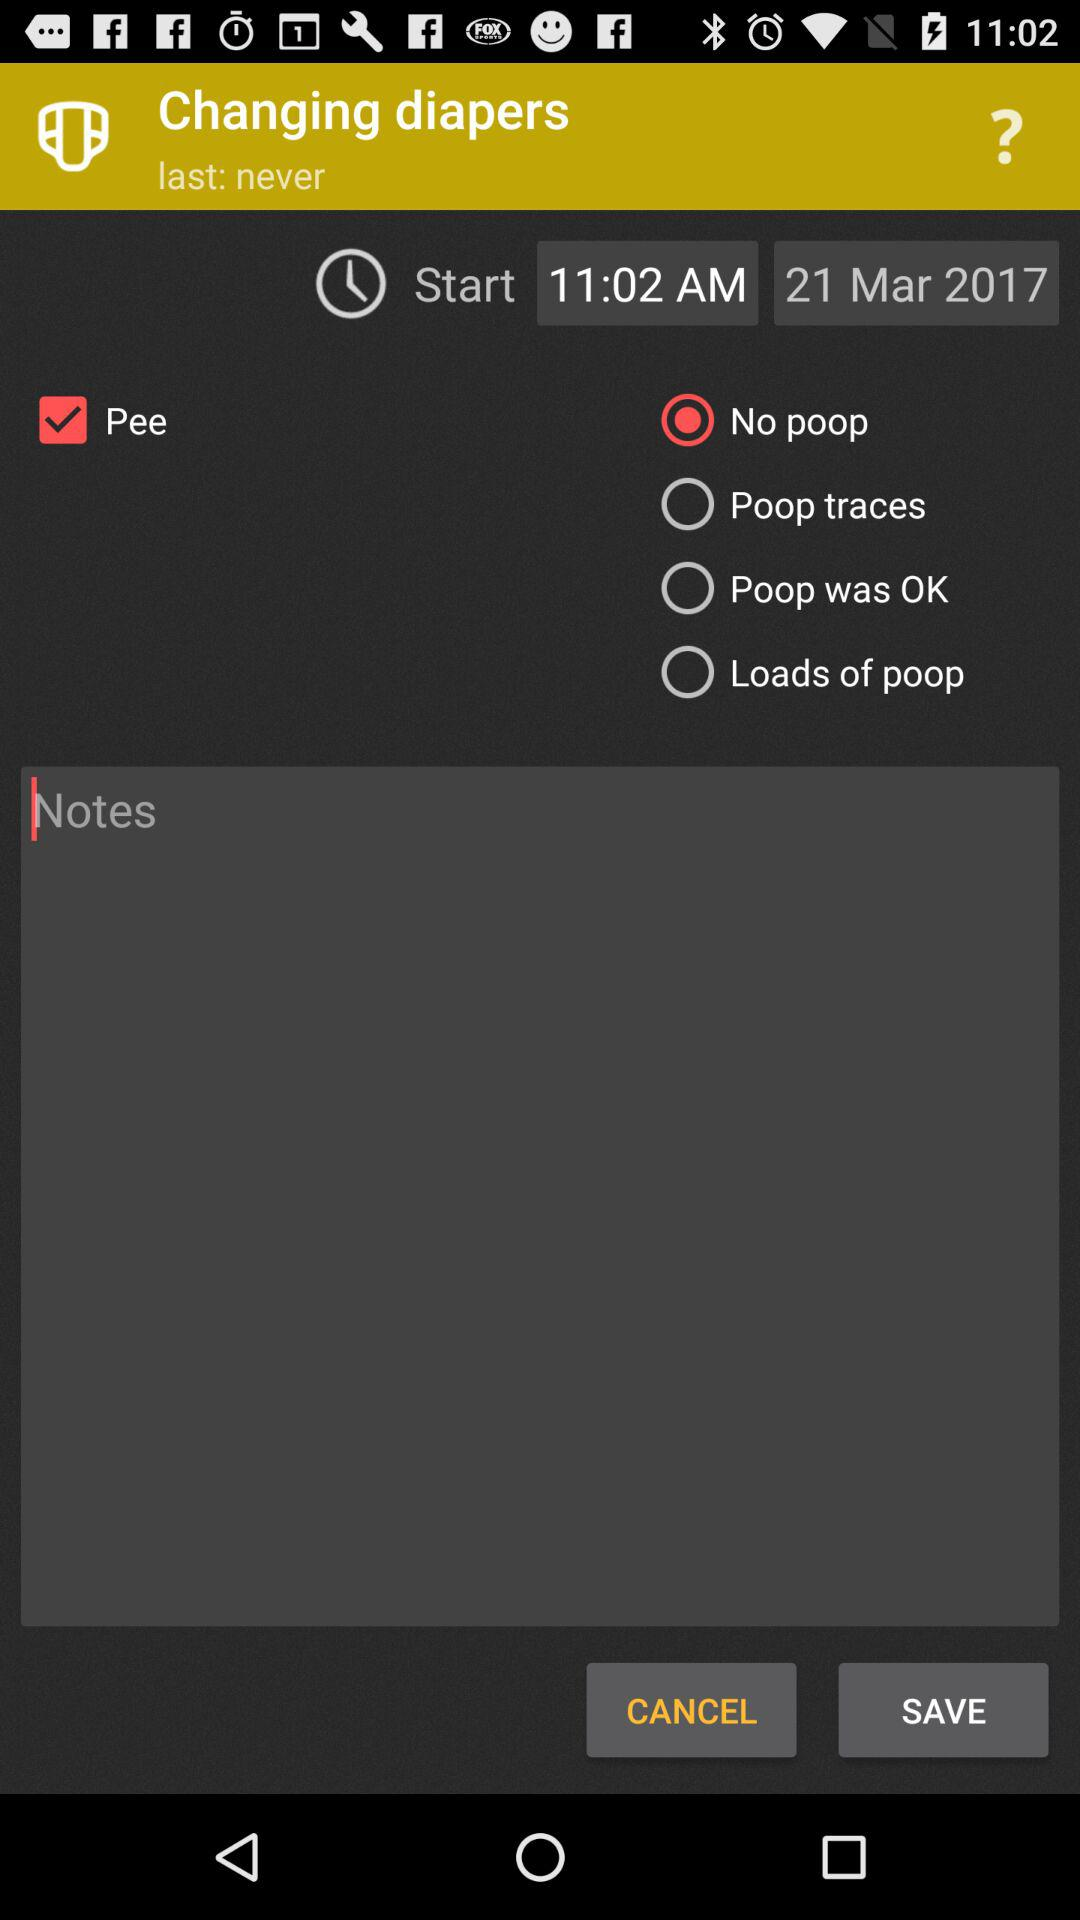How many poop options are there?
Answer the question using a single word or phrase. 4 